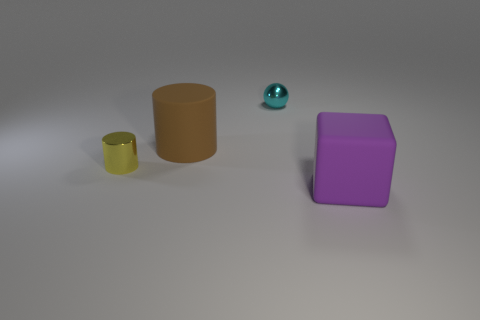The tiny object behind the big rubber thing that is behind the large matte object that is in front of the big matte cylinder is made of what material?
Make the answer very short. Metal. How many large blue shiny cubes are there?
Your answer should be very brief. 0. What number of red objects are either rubber objects or small cylinders?
Ensure brevity in your answer.  0. What number of other objects are the same shape as the small yellow metallic object?
Offer a very short reply. 1. Does the big thing that is behind the large matte block have the same color as the metallic object that is in front of the large brown cylinder?
Provide a succinct answer. No. What number of big things are purple things or metallic things?
Your answer should be very brief. 1. What is the size of the other metallic object that is the same shape as the brown thing?
Offer a terse response. Small. There is a tiny object that is behind the large object that is on the left side of the big rubber block; what is it made of?
Your answer should be compact. Metal. What number of shiny things are blocks or large purple balls?
Your response must be concise. 0. What color is the other matte object that is the same shape as the yellow object?
Your response must be concise. Brown. 